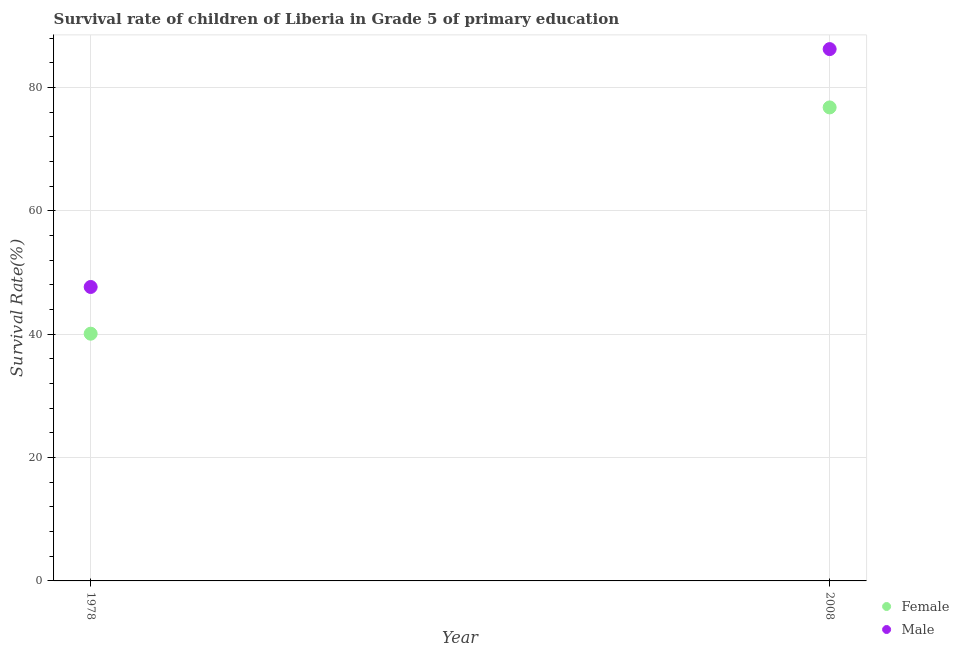How many different coloured dotlines are there?
Keep it short and to the point. 2. Is the number of dotlines equal to the number of legend labels?
Offer a terse response. Yes. What is the survival rate of female students in primary education in 1978?
Make the answer very short. 40.09. Across all years, what is the maximum survival rate of male students in primary education?
Keep it short and to the point. 86.25. Across all years, what is the minimum survival rate of male students in primary education?
Give a very brief answer. 47.67. In which year was the survival rate of female students in primary education maximum?
Keep it short and to the point. 2008. In which year was the survival rate of female students in primary education minimum?
Make the answer very short. 1978. What is the total survival rate of female students in primary education in the graph?
Offer a very short reply. 116.88. What is the difference between the survival rate of male students in primary education in 1978 and that in 2008?
Your answer should be very brief. -38.58. What is the difference between the survival rate of male students in primary education in 1978 and the survival rate of female students in primary education in 2008?
Keep it short and to the point. -29.12. What is the average survival rate of female students in primary education per year?
Your answer should be compact. 58.44. In the year 2008, what is the difference between the survival rate of female students in primary education and survival rate of male students in primary education?
Keep it short and to the point. -9.46. What is the ratio of the survival rate of male students in primary education in 1978 to that in 2008?
Your answer should be very brief. 0.55. Is the survival rate of male students in primary education strictly greater than the survival rate of female students in primary education over the years?
Your answer should be compact. Yes. How many dotlines are there?
Keep it short and to the point. 2. How many years are there in the graph?
Provide a short and direct response. 2. What is the difference between two consecutive major ticks on the Y-axis?
Your answer should be compact. 20. Does the graph contain any zero values?
Offer a very short reply. No. How are the legend labels stacked?
Ensure brevity in your answer.  Vertical. What is the title of the graph?
Offer a very short reply. Survival rate of children of Liberia in Grade 5 of primary education. What is the label or title of the X-axis?
Make the answer very short. Year. What is the label or title of the Y-axis?
Make the answer very short. Survival Rate(%). What is the Survival Rate(%) in Female in 1978?
Your response must be concise. 40.09. What is the Survival Rate(%) in Male in 1978?
Provide a succinct answer. 47.67. What is the Survival Rate(%) of Female in 2008?
Offer a very short reply. 76.79. What is the Survival Rate(%) of Male in 2008?
Your answer should be compact. 86.25. Across all years, what is the maximum Survival Rate(%) in Female?
Your answer should be compact. 76.79. Across all years, what is the maximum Survival Rate(%) of Male?
Provide a short and direct response. 86.25. Across all years, what is the minimum Survival Rate(%) of Female?
Offer a terse response. 40.09. Across all years, what is the minimum Survival Rate(%) of Male?
Offer a very short reply. 47.67. What is the total Survival Rate(%) of Female in the graph?
Provide a succinct answer. 116.88. What is the total Survival Rate(%) in Male in the graph?
Offer a very short reply. 133.92. What is the difference between the Survival Rate(%) of Female in 1978 and that in 2008?
Provide a short and direct response. -36.7. What is the difference between the Survival Rate(%) in Male in 1978 and that in 2008?
Provide a short and direct response. -38.58. What is the difference between the Survival Rate(%) in Female in 1978 and the Survival Rate(%) in Male in 2008?
Your response must be concise. -46.15. What is the average Survival Rate(%) of Female per year?
Offer a very short reply. 58.44. What is the average Survival Rate(%) in Male per year?
Your answer should be very brief. 66.96. In the year 1978, what is the difference between the Survival Rate(%) of Female and Survival Rate(%) of Male?
Keep it short and to the point. -7.58. In the year 2008, what is the difference between the Survival Rate(%) of Female and Survival Rate(%) of Male?
Ensure brevity in your answer.  -9.46. What is the ratio of the Survival Rate(%) in Female in 1978 to that in 2008?
Offer a very short reply. 0.52. What is the ratio of the Survival Rate(%) of Male in 1978 to that in 2008?
Offer a terse response. 0.55. What is the difference between the highest and the second highest Survival Rate(%) of Female?
Give a very brief answer. 36.7. What is the difference between the highest and the second highest Survival Rate(%) of Male?
Give a very brief answer. 38.58. What is the difference between the highest and the lowest Survival Rate(%) of Female?
Your answer should be compact. 36.7. What is the difference between the highest and the lowest Survival Rate(%) in Male?
Your answer should be very brief. 38.58. 